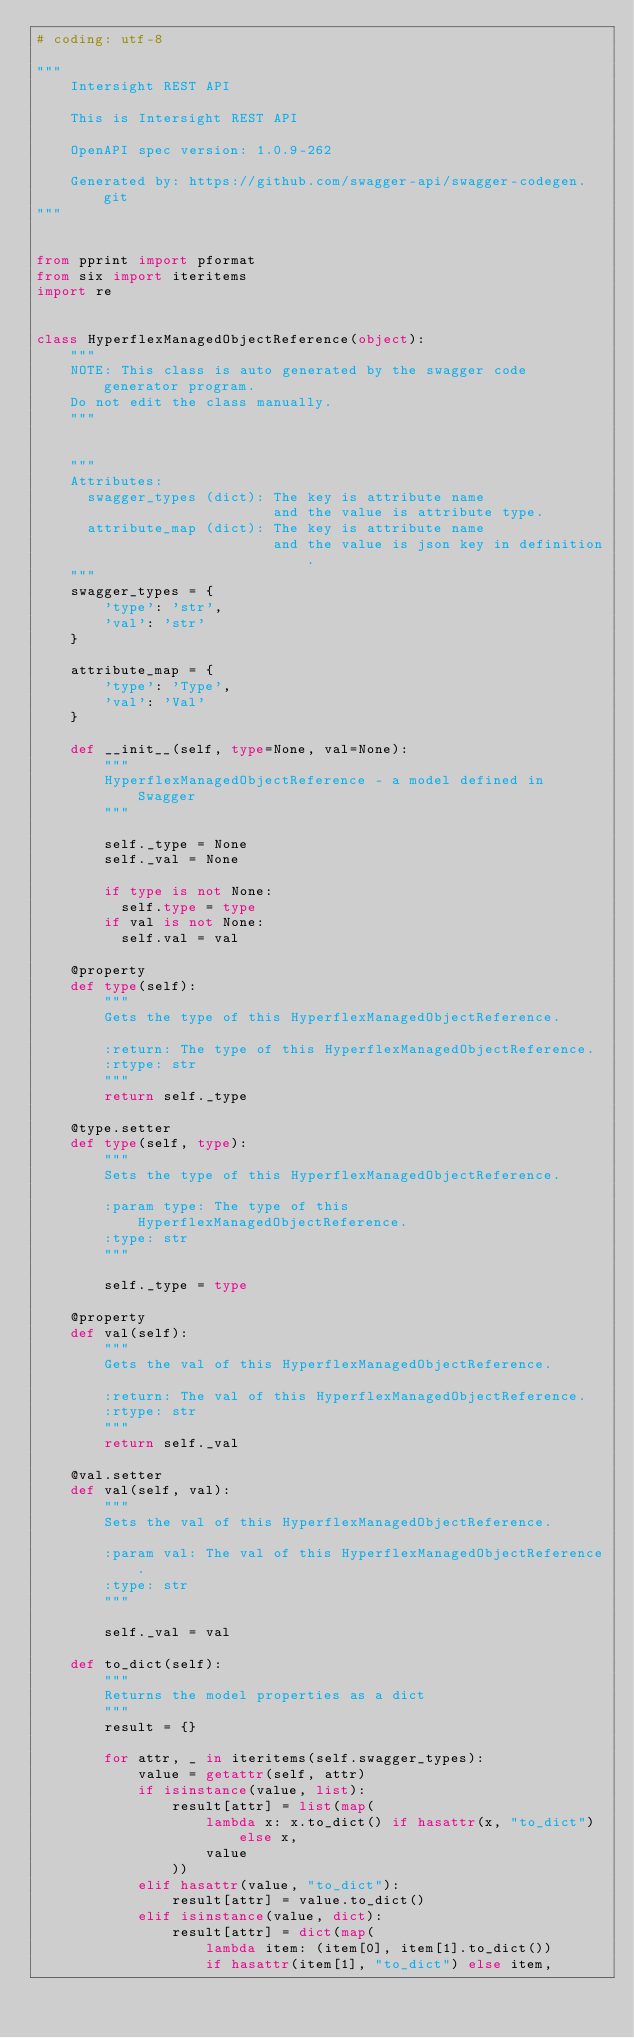Convert code to text. <code><loc_0><loc_0><loc_500><loc_500><_Python_># coding: utf-8

"""
    Intersight REST API

    This is Intersight REST API 

    OpenAPI spec version: 1.0.9-262
    
    Generated by: https://github.com/swagger-api/swagger-codegen.git
"""


from pprint import pformat
from six import iteritems
import re


class HyperflexManagedObjectReference(object):
    """
    NOTE: This class is auto generated by the swagger code generator program.
    Do not edit the class manually.
    """


    """
    Attributes:
      swagger_types (dict): The key is attribute name
                            and the value is attribute type.
      attribute_map (dict): The key is attribute name
                            and the value is json key in definition.
    """
    swagger_types = {
        'type': 'str',
        'val': 'str'
    }

    attribute_map = {
        'type': 'Type',
        'val': 'Val'
    }

    def __init__(self, type=None, val=None):
        """
        HyperflexManagedObjectReference - a model defined in Swagger
        """

        self._type = None
        self._val = None

        if type is not None:
          self.type = type
        if val is not None:
          self.val = val

    @property
    def type(self):
        """
        Gets the type of this HyperflexManagedObjectReference.

        :return: The type of this HyperflexManagedObjectReference.
        :rtype: str
        """
        return self._type

    @type.setter
    def type(self, type):
        """
        Sets the type of this HyperflexManagedObjectReference.

        :param type: The type of this HyperflexManagedObjectReference.
        :type: str
        """

        self._type = type

    @property
    def val(self):
        """
        Gets the val of this HyperflexManagedObjectReference.

        :return: The val of this HyperflexManagedObjectReference.
        :rtype: str
        """
        return self._val

    @val.setter
    def val(self, val):
        """
        Sets the val of this HyperflexManagedObjectReference.

        :param val: The val of this HyperflexManagedObjectReference.
        :type: str
        """

        self._val = val

    def to_dict(self):
        """
        Returns the model properties as a dict
        """
        result = {}

        for attr, _ in iteritems(self.swagger_types):
            value = getattr(self, attr)
            if isinstance(value, list):
                result[attr] = list(map(
                    lambda x: x.to_dict() if hasattr(x, "to_dict") else x,
                    value
                ))
            elif hasattr(value, "to_dict"):
                result[attr] = value.to_dict()
            elif isinstance(value, dict):
                result[attr] = dict(map(
                    lambda item: (item[0], item[1].to_dict())
                    if hasattr(item[1], "to_dict") else item,</code> 